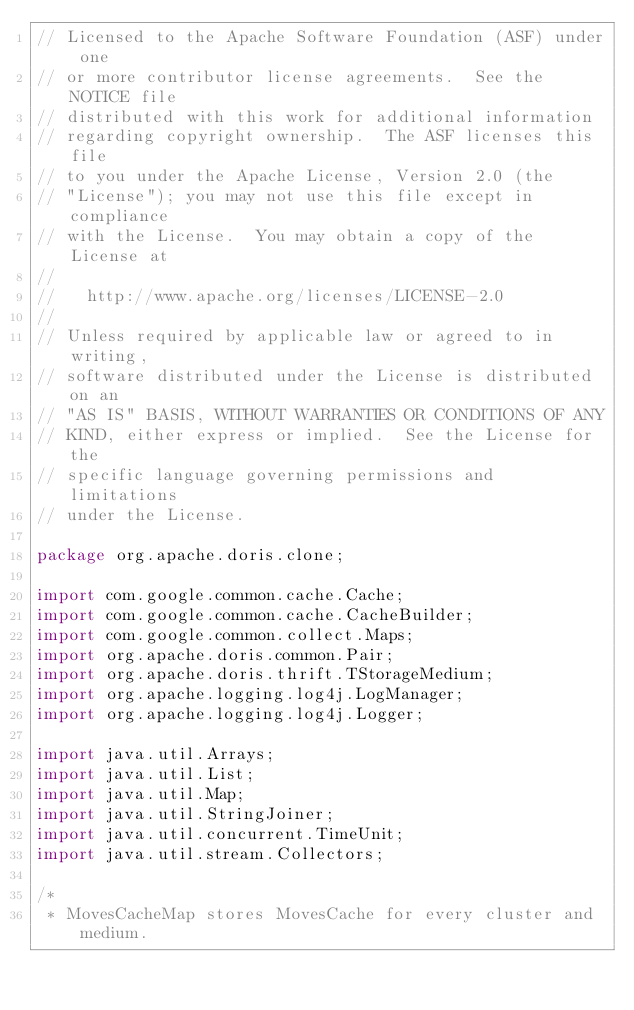Convert code to text. <code><loc_0><loc_0><loc_500><loc_500><_Java_>// Licensed to the Apache Software Foundation (ASF) under one
// or more contributor license agreements.  See the NOTICE file
// distributed with this work for additional information
// regarding copyright ownership.  The ASF licenses this file
// to you under the Apache License, Version 2.0 (the
// "License"); you may not use this file except in compliance
// with the License.  You may obtain a copy of the License at
//
//   http://www.apache.org/licenses/LICENSE-2.0
//
// Unless required by applicable law or agreed to in writing,
// software distributed under the License is distributed on an
// "AS IS" BASIS, WITHOUT WARRANTIES OR CONDITIONS OF ANY
// KIND, either express or implied.  See the License for the
// specific language governing permissions and limitations
// under the License.

package org.apache.doris.clone;

import com.google.common.cache.Cache;
import com.google.common.cache.CacheBuilder;
import com.google.common.collect.Maps;
import org.apache.doris.common.Pair;
import org.apache.doris.thrift.TStorageMedium;
import org.apache.logging.log4j.LogManager;
import org.apache.logging.log4j.Logger;

import java.util.Arrays;
import java.util.List;
import java.util.Map;
import java.util.StringJoiner;
import java.util.concurrent.TimeUnit;
import java.util.stream.Collectors;

/*
 * MovesCacheMap stores MovesCache for every cluster and medium.</code> 